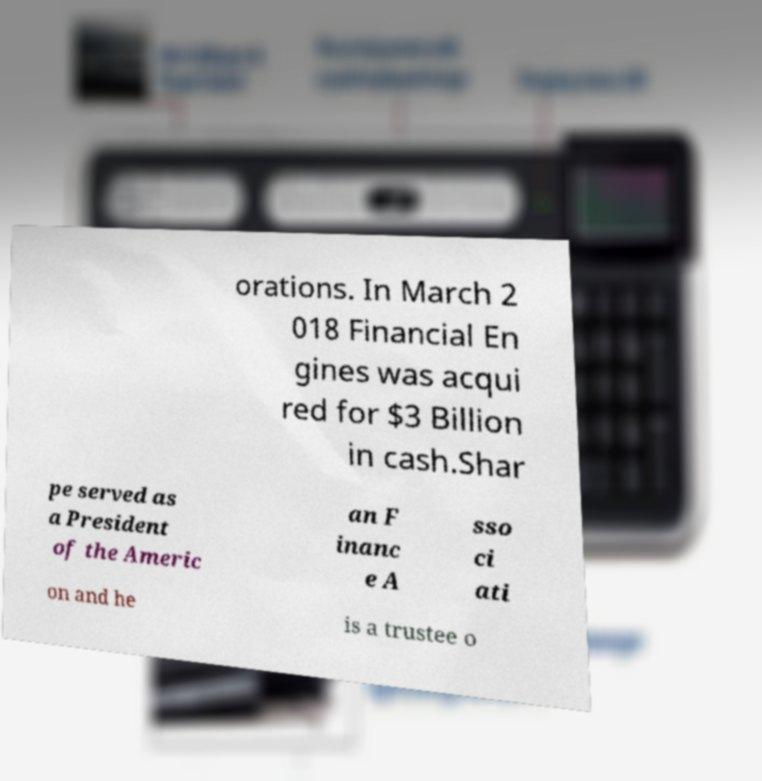Can you read and provide the text displayed in the image?This photo seems to have some interesting text. Can you extract and type it out for me? orations. In March 2 018 Financial En gines was acqui red for $3 Billion in cash.Shar pe served as a President of the Americ an F inanc e A sso ci ati on and he is a trustee o 